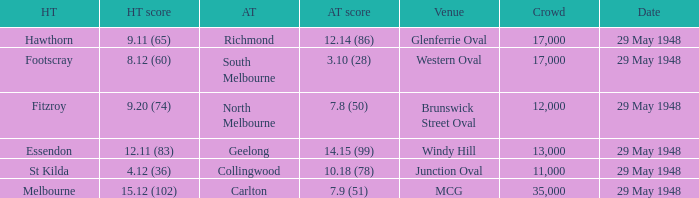In the match where north melbourne was the away team, how much did the home team score? 9.20 (74). 